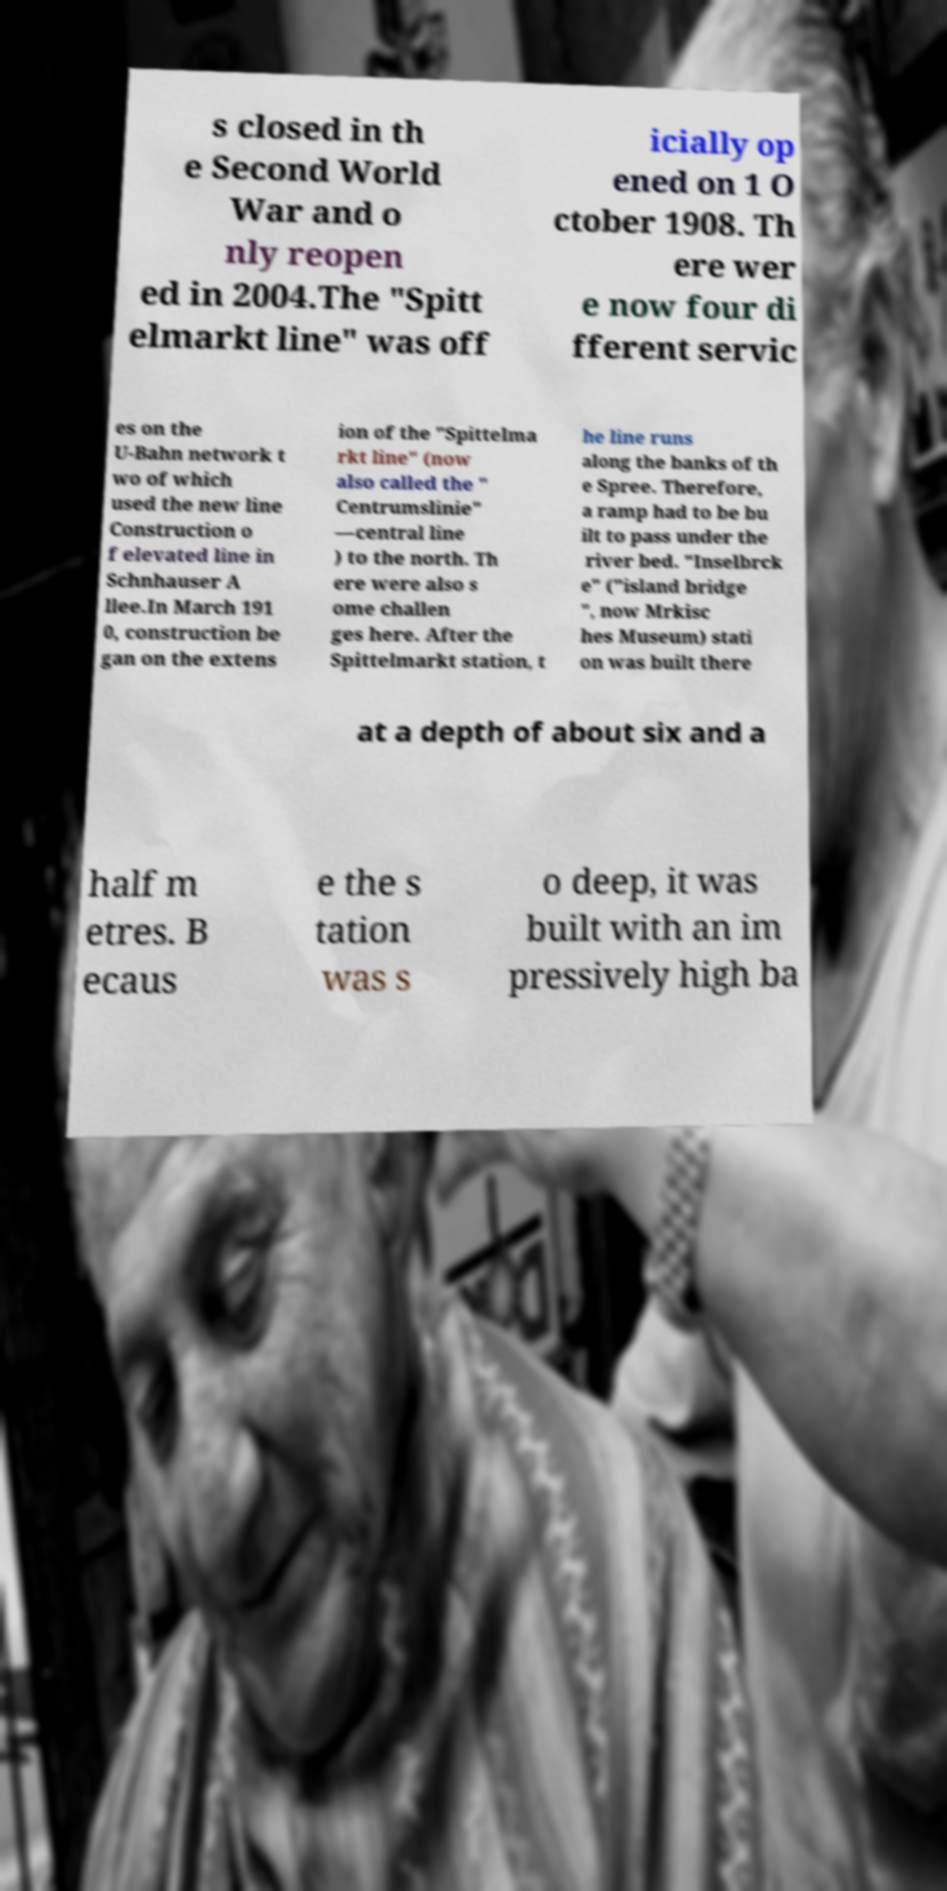There's text embedded in this image that I need extracted. Can you transcribe it verbatim? s closed in th e Second World War and o nly reopen ed in 2004.The "Spitt elmarkt line" was off icially op ened on 1 O ctober 1908. Th ere wer e now four di fferent servic es on the U-Bahn network t wo of which used the new line Construction o f elevated line in Schnhauser A llee.In March 191 0, construction be gan on the extens ion of the "Spittelma rkt line" (now also called the " Centrumslinie" —central line ) to the north. Th ere were also s ome challen ges here. After the Spittelmarkt station, t he line runs along the banks of th e Spree. Therefore, a ramp had to be bu ilt to pass under the river bed. "Inselbrck e" ("island bridge ", now Mrkisc hes Museum) stati on was built there at a depth of about six and a half m etres. B ecaus e the s tation was s o deep, it was built with an im pressively high ba 